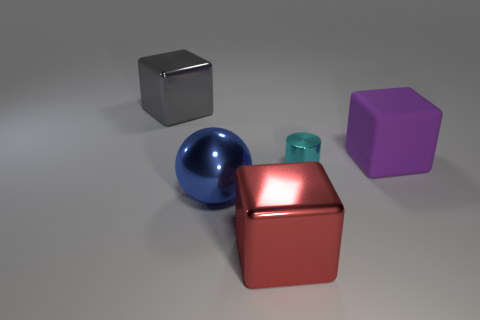Subtract all shiny cubes. How many cubes are left? 1 Add 4 cyan rubber blocks. How many objects exist? 9 Subtract 0 brown cubes. How many objects are left? 5 Subtract all balls. How many objects are left? 4 Subtract all yellow blocks. Subtract all blue spheres. How many blocks are left? 3 Subtract all cyan spheres. Subtract all gray objects. How many objects are left? 4 Add 3 blue metal objects. How many blue metal objects are left? 4 Add 1 yellow metallic spheres. How many yellow metallic spheres exist? 1 